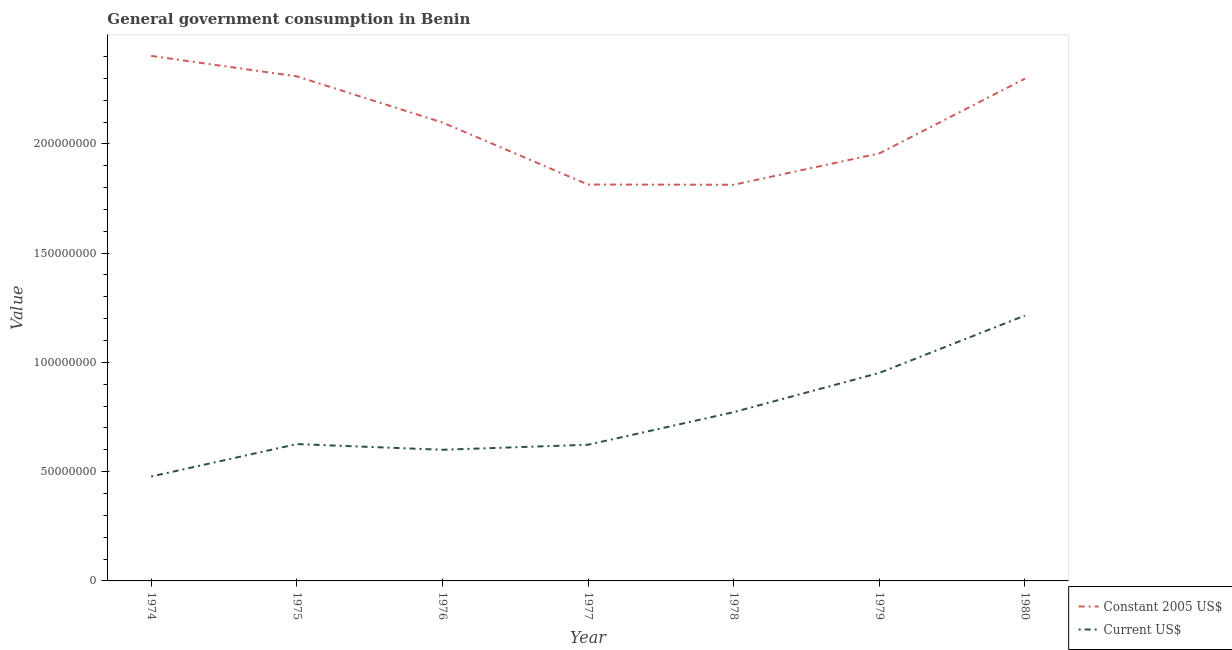Does the line corresponding to value consumed in constant 2005 us$ intersect with the line corresponding to value consumed in current us$?
Provide a succinct answer. No. Is the number of lines equal to the number of legend labels?
Your answer should be very brief. Yes. What is the value consumed in constant 2005 us$ in 1976?
Ensure brevity in your answer.  2.10e+08. Across all years, what is the maximum value consumed in current us$?
Give a very brief answer. 1.21e+08. Across all years, what is the minimum value consumed in constant 2005 us$?
Ensure brevity in your answer.  1.81e+08. In which year was the value consumed in constant 2005 us$ minimum?
Provide a succinct answer. 1978. What is the total value consumed in constant 2005 us$ in the graph?
Offer a very short reply. 1.47e+09. What is the difference between the value consumed in current us$ in 1976 and that in 1978?
Your answer should be very brief. -1.72e+07. What is the difference between the value consumed in constant 2005 us$ in 1979 and the value consumed in current us$ in 1978?
Make the answer very short. 1.18e+08. What is the average value consumed in current us$ per year?
Make the answer very short. 7.52e+07. In the year 1975, what is the difference between the value consumed in constant 2005 us$ and value consumed in current us$?
Ensure brevity in your answer.  1.68e+08. What is the ratio of the value consumed in constant 2005 us$ in 1977 to that in 1980?
Offer a terse response. 0.79. Is the value consumed in constant 2005 us$ in 1975 less than that in 1977?
Your response must be concise. No. What is the difference between the highest and the second highest value consumed in constant 2005 us$?
Make the answer very short. 9.36e+06. What is the difference between the highest and the lowest value consumed in constant 2005 us$?
Ensure brevity in your answer.  5.90e+07. Is the sum of the value consumed in constant 2005 us$ in 1977 and 1979 greater than the maximum value consumed in current us$ across all years?
Your answer should be compact. Yes. Does the value consumed in constant 2005 us$ monotonically increase over the years?
Your answer should be compact. No. Is the value consumed in current us$ strictly greater than the value consumed in constant 2005 us$ over the years?
Give a very brief answer. No. Is the value consumed in constant 2005 us$ strictly less than the value consumed in current us$ over the years?
Give a very brief answer. No. How many years are there in the graph?
Your response must be concise. 7. Are the values on the major ticks of Y-axis written in scientific E-notation?
Make the answer very short. No. Does the graph contain grids?
Give a very brief answer. No. How many legend labels are there?
Your answer should be very brief. 2. How are the legend labels stacked?
Give a very brief answer. Vertical. What is the title of the graph?
Offer a very short reply. General government consumption in Benin. Does "Primary completion rate" appear as one of the legend labels in the graph?
Keep it short and to the point. No. What is the label or title of the X-axis?
Provide a short and direct response. Year. What is the label or title of the Y-axis?
Provide a short and direct response. Value. What is the Value in Constant 2005 US$ in 1974?
Offer a terse response. 2.40e+08. What is the Value of Current US$ in 1974?
Provide a succinct answer. 4.78e+07. What is the Value of Constant 2005 US$ in 1975?
Keep it short and to the point. 2.31e+08. What is the Value in Current US$ in 1975?
Provide a short and direct response. 6.26e+07. What is the Value in Constant 2005 US$ in 1976?
Make the answer very short. 2.10e+08. What is the Value of Current US$ in 1976?
Provide a short and direct response. 6.00e+07. What is the Value of Constant 2005 US$ in 1977?
Offer a very short reply. 1.81e+08. What is the Value in Current US$ in 1977?
Your response must be concise. 6.23e+07. What is the Value of Constant 2005 US$ in 1978?
Your response must be concise. 1.81e+08. What is the Value of Current US$ in 1978?
Make the answer very short. 7.72e+07. What is the Value in Constant 2005 US$ in 1979?
Provide a short and direct response. 1.96e+08. What is the Value in Current US$ in 1979?
Give a very brief answer. 9.52e+07. What is the Value in Constant 2005 US$ in 1980?
Offer a terse response. 2.30e+08. What is the Value of Current US$ in 1980?
Make the answer very short. 1.21e+08. Across all years, what is the maximum Value in Constant 2005 US$?
Your answer should be very brief. 2.40e+08. Across all years, what is the maximum Value in Current US$?
Make the answer very short. 1.21e+08. Across all years, what is the minimum Value of Constant 2005 US$?
Keep it short and to the point. 1.81e+08. Across all years, what is the minimum Value of Current US$?
Keep it short and to the point. 4.78e+07. What is the total Value of Constant 2005 US$ in the graph?
Offer a terse response. 1.47e+09. What is the total Value of Current US$ in the graph?
Give a very brief answer. 5.27e+08. What is the difference between the Value of Constant 2005 US$ in 1974 and that in 1975?
Provide a short and direct response. 9.36e+06. What is the difference between the Value of Current US$ in 1974 and that in 1975?
Give a very brief answer. -1.48e+07. What is the difference between the Value of Constant 2005 US$ in 1974 and that in 1976?
Your response must be concise. 3.05e+07. What is the difference between the Value in Current US$ in 1974 and that in 1976?
Offer a terse response. -1.22e+07. What is the difference between the Value of Constant 2005 US$ in 1974 and that in 1977?
Ensure brevity in your answer.  5.89e+07. What is the difference between the Value of Current US$ in 1974 and that in 1977?
Provide a succinct answer. -1.45e+07. What is the difference between the Value in Constant 2005 US$ in 1974 and that in 1978?
Your answer should be very brief. 5.90e+07. What is the difference between the Value of Current US$ in 1974 and that in 1978?
Offer a very short reply. -2.95e+07. What is the difference between the Value in Constant 2005 US$ in 1974 and that in 1979?
Keep it short and to the point. 4.46e+07. What is the difference between the Value in Current US$ in 1974 and that in 1979?
Provide a succinct answer. -4.74e+07. What is the difference between the Value in Constant 2005 US$ in 1974 and that in 1980?
Your answer should be very brief. 1.04e+07. What is the difference between the Value of Current US$ in 1974 and that in 1980?
Keep it short and to the point. -7.37e+07. What is the difference between the Value of Constant 2005 US$ in 1975 and that in 1976?
Your answer should be very brief. 2.11e+07. What is the difference between the Value in Current US$ in 1975 and that in 1976?
Your answer should be compact. 2.61e+06. What is the difference between the Value of Constant 2005 US$ in 1975 and that in 1977?
Give a very brief answer. 4.95e+07. What is the difference between the Value in Current US$ in 1975 and that in 1977?
Give a very brief answer. 3.02e+05. What is the difference between the Value in Constant 2005 US$ in 1975 and that in 1978?
Give a very brief answer. 4.96e+07. What is the difference between the Value in Current US$ in 1975 and that in 1978?
Your answer should be compact. -1.46e+07. What is the difference between the Value of Constant 2005 US$ in 1975 and that in 1979?
Your answer should be compact. 3.53e+07. What is the difference between the Value of Current US$ in 1975 and that in 1979?
Make the answer very short. -3.26e+07. What is the difference between the Value in Constant 2005 US$ in 1975 and that in 1980?
Your answer should be compact. 1.04e+06. What is the difference between the Value of Current US$ in 1975 and that in 1980?
Provide a succinct answer. -5.88e+07. What is the difference between the Value in Constant 2005 US$ in 1976 and that in 1977?
Keep it short and to the point. 2.84e+07. What is the difference between the Value in Current US$ in 1976 and that in 1977?
Give a very brief answer. -2.30e+06. What is the difference between the Value of Constant 2005 US$ in 1976 and that in 1978?
Ensure brevity in your answer.  2.85e+07. What is the difference between the Value of Current US$ in 1976 and that in 1978?
Provide a short and direct response. -1.72e+07. What is the difference between the Value of Constant 2005 US$ in 1976 and that in 1979?
Make the answer very short. 1.41e+07. What is the difference between the Value in Current US$ in 1976 and that in 1979?
Your answer should be compact. -3.52e+07. What is the difference between the Value of Constant 2005 US$ in 1976 and that in 1980?
Keep it short and to the point. -2.01e+07. What is the difference between the Value of Current US$ in 1976 and that in 1980?
Provide a short and direct response. -6.14e+07. What is the difference between the Value of Constant 2005 US$ in 1977 and that in 1978?
Provide a succinct answer. 1.04e+05. What is the difference between the Value in Current US$ in 1977 and that in 1978?
Give a very brief answer. -1.49e+07. What is the difference between the Value in Constant 2005 US$ in 1977 and that in 1979?
Your response must be concise. -1.42e+07. What is the difference between the Value in Current US$ in 1977 and that in 1979?
Give a very brief answer. -3.29e+07. What is the difference between the Value of Constant 2005 US$ in 1977 and that in 1980?
Your response must be concise. -4.85e+07. What is the difference between the Value in Current US$ in 1977 and that in 1980?
Your answer should be compact. -5.91e+07. What is the difference between the Value in Constant 2005 US$ in 1978 and that in 1979?
Provide a succinct answer. -1.44e+07. What is the difference between the Value of Current US$ in 1978 and that in 1979?
Your answer should be very brief. -1.80e+07. What is the difference between the Value of Constant 2005 US$ in 1978 and that in 1980?
Provide a short and direct response. -4.86e+07. What is the difference between the Value of Current US$ in 1978 and that in 1980?
Your response must be concise. -4.42e+07. What is the difference between the Value in Constant 2005 US$ in 1979 and that in 1980?
Your answer should be compact. -3.42e+07. What is the difference between the Value in Current US$ in 1979 and that in 1980?
Ensure brevity in your answer.  -2.63e+07. What is the difference between the Value of Constant 2005 US$ in 1974 and the Value of Current US$ in 1975?
Give a very brief answer. 1.78e+08. What is the difference between the Value in Constant 2005 US$ in 1974 and the Value in Current US$ in 1976?
Give a very brief answer. 1.80e+08. What is the difference between the Value in Constant 2005 US$ in 1974 and the Value in Current US$ in 1977?
Offer a terse response. 1.78e+08. What is the difference between the Value in Constant 2005 US$ in 1974 and the Value in Current US$ in 1978?
Make the answer very short. 1.63e+08. What is the difference between the Value in Constant 2005 US$ in 1974 and the Value in Current US$ in 1979?
Your answer should be very brief. 1.45e+08. What is the difference between the Value of Constant 2005 US$ in 1974 and the Value of Current US$ in 1980?
Ensure brevity in your answer.  1.19e+08. What is the difference between the Value of Constant 2005 US$ in 1975 and the Value of Current US$ in 1976?
Make the answer very short. 1.71e+08. What is the difference between the Value of Constant 2005 US$ in 1975 and the Value of Current US$ in 1977?
Give a very brief answer. 1.69e+08. What is the difference between the Value of Constant 2005 US$ in 1975 and the Value of Current US$ in 1978?
Your response must be concise. 1.54e+08. What is the difference between the Value of Constant 2005 US$ in 1975 and the Value of Current US$ in 1979?
Your response must be concise. 1.36e+08. What is the difference between the Value of Constant 2005 US$ in 1975 and the Value of Current US$ in 1980?
Give a very brief answer. 1.09e+08. What is the difference between the Value of Constant 2005 US$ in 1976 and the Value of Current US$ in 1977?
Provide a short and direct response. 1.47e+08. What is the difference between the Value of Constant 2005 US$ in 1976 and the Value of Current US$ in 1978?
Offer a terse response. 1.33e+08. What is the difference between the Value of Constant 2005 US$ in 1976 and the Value of Current US$ in 1979?
Your response must be concise. 1.15e+08. What is the difference between the Value of Constant 2005 US$ in 1976 and the Value of Current US$ in 1980?
Provide a short and direct response. 8.83e+07. What is the difference between the Value of Constant 2005 US$ in 1977 and the Value of Current US$ in 1978?
Make the answer very short. 1.04e+08. What is the difference between the Value in Constant 2005 US$ in 1977 and the Value in Current US$ in 1979?
Provide a short and direct response. 8.62e+07. What is the difference between the Value of Constant 2005 US$ in 1977 and the Value of Current US$ in 1980?
Make the answer very short. 5.99e+07. What is the difference between the Value of Constant 2005 US$ in 1978 and the Value of Current US$ in 1979?
Your answer should be very brief. 8.61e+07. What is the difference between the Value in Constant 2005 US$ in 1978 and the Value in Current US$ in 1980?
Offer a very short reply. 5.98e+07. What is the difference between the Value in Constant 2005 US$ in 1979 and the Value in Current US$ in 1980?
Keep it short and to the point. 7.42e+07. What is the average Value in Constant 2005 US$ per year?
Your answer should be compact. 2.10e+08. What is the average Value of Current US$ per year?
Make the answer very short. 7.52e+07. In the year 1974, what is the difference between the Value in Constant 2005 US$ and Value in Current US$?
Your answer should be very brief. 1.92e+08. In the year 1975, what is the difference between the Value in Constant 2005 US$ and Value in Current US$?
Your answer should be compact. 1.68e+08. In the year 1976, what is the difference between the Value in Constant 2005 US$ and Value in Current US$?
Your answer should be very brief. 1.50e+08. In the year 1977, what is the difference between the Value of Constant 2005 US$ and Value of Current US$?
Offer a very short reply. 1.19e+08. In the year 1978, what is the difference between the Value in Constant 2005 US$ and Value in Current US$?
Keep it short and to the point. 1.04e+08. In the year 1979, what is the difference between the Value of Constant 2005 US$ and Value of Current US$?
Provide a succinct answer. 1.00e+08. In the year 1980, what is the difference between the Value of Constant 2005 US$ and Value of Current US$?
Ensure brevity in your answer.  1.08e+08. What is the ratio of the Value in Constant 2005 US$ in 1974 to that in 1975?
Offer a very short reply. 1.04. What is the ratio of the Value of Current US$ in 1974 to that in 1975?
Make the answer very short. 0.76. What is the ratio of the Value of Constant 2005 US$ in 1974 to that in 1976?
Give a very brief answer. 1.15. What is the ratio of the Value in Current US$ in 1974 to that in 1976?
Provide a short and direct response. 0.8. What is the ratio of the Value in Constant 2005 US$ in 1974 to that in 1977?
Ensure brevity in your answer.  1.32. What is the ratio of the Value in Current US$ in 1974 to that in 1977?
Provide a short and direct response. 0.77. What is the ratio of the Value of Constant 2005 US$ in 1974 to that in 1978?
Make the answer very short. 1.33. What is the ratio of the Value of Current US$ in 1974 to that in 1978?
Provide a short and direct response. 0.62. What is the ratio of the Value in Constant 2005 US$ in 1974 to that in 1979?
Keep it short and to the point. 1.23. What is the ratio of the Value of Current US$ in 1974 to that in 1979?
Your answer should be compact. 0.5. What is the ratio of the Value in Constant 2005 US$ in 1974 to that in 1980?
Your response must be concise. 1.05. What is the ratio of the Value in Current US$ in 1974 to that in 1980?
Offer a very short reply. 0.39. What is the ratio of the Value of Constant 2005 US$ in 1975 to that in 1976?
Offer a very short reply. 1.1. What is the ratio of the Value in Current US$ in 1975 to that in 1976?
Your answer should be compact. 1.04. What is the ratio of the Value of Constant 2005 US$ in 1975 to that in 1977?
Your response must be concise. 1.27. What is the ratio of the Value of Current US$ in 1975 to that in 1977?
Keep it short and to the point. 1. What is the ratio of the Value in Constant 2005 US$ in 1975 to that in 1978?
Offer a very short reply. 1.27. What is the ratio of the Value of Current US$ in 1975 to that in 1978?
Keep it short and to the point. 0.81. What is the ratio of the Value of Constant 2005 US$ in 1975 to that in 1979?
Keep it short and to the point. 1.18. What is the ratio of the Value of Current US$ in 1975 to that in 1979?
Make the answer very short. 0.66. What is the ratio of the Value of Current US$ in 1975 to that in 1980?
Offer a very short reply. 0.52. What is the ratio of the Value of Constant 2005 US$ in 1976 to that in 1977?
Provide a short and direct response. 1.16. What is the ratio of the Value of Constant 2005 US$ in 1976 to that in 1978?
Your answer should be compact. 1.16. What is the ratio of the Value in Current US$ in 1976 to that in 1978?
Your response must be concise. 0.78. What is the ratio of the Value of Constant 2005 US$ in 1976 to that in 1979?
Offer a terse response. 1.07. What is the ratio of the Value in Current US$ in 1976 to that in 1979?
Offer a very short reply. 0.63. What is the ratio of the Value in Constant 2005 US$ in 1976 to that in 1980?
Provide a succinct answer. 0.91. What is the ratio of the Value in Current US$ in 1976 to that in 1980?
Ensure brevity in your answer.  0.49. What is the ratio of the Value of Constant 2005 US$ in 1977 to that in 1978?
Ensure brevity in your answer.  1. What is the ratio of the Value of Current US$ in 1977 to that in 1978?
Your response must be concise. 0.81. What is the ratio of the Value in Constant 2005 US$ in 1977 to that in 1979?
Your answer should be compact. 0.93. What is the ratio of the Value of Current US$ in 1977 to that in 1979?
Provide a succinct answer. 0.65. What is the ratio of the Value in Constant 2005 US$ in 1977 to that in 1980?
Keep it short and to the point. 0.79. What is the ratio of the Value of Current US$ in 1977 to that in 1980?
Your answer should be compact. 0.51. What is the ratio of the Value of Constant 2005 US$ in 1978 to that in 1979?
Offer a terse response. 0.93. What is the ratio of the Value in Current US$ in 1978 to that in 1979?
Your answer should be very brief. 0.81. What is the ratio of the Value in Constant 2005 US$ in 1978 to that in 1980?
Your answer should be very brief. 0.79. What is the ratio of the Value in Current US$ in 1978 to that in 1980?
Your answer should be compact. 0.64. What is the ratio of the Value of Constant 2005 US$ in 1979 to that in 1980?
Your answer should be compact. 0.85. What is the ratio of the Value in Current US$ in 1979 to that in 1980?
Keep it short and to the point. 0.78. What is the difference between the highest and the second highest Value in Constant 2005 US$?
Your answer should be very brief. 9.36e+06. What is the difference between the highest and the second highest Value in Current US$?
Your answer should be compact. 2.63e+07. What is the difference between the highest and the lowest Value in Constant 2005 US$?
Offer a terse response. 5.90e+07. What is the difference between the highest and the lowest Value of Current US$?
Offer a terse response. 7.37e+07. 